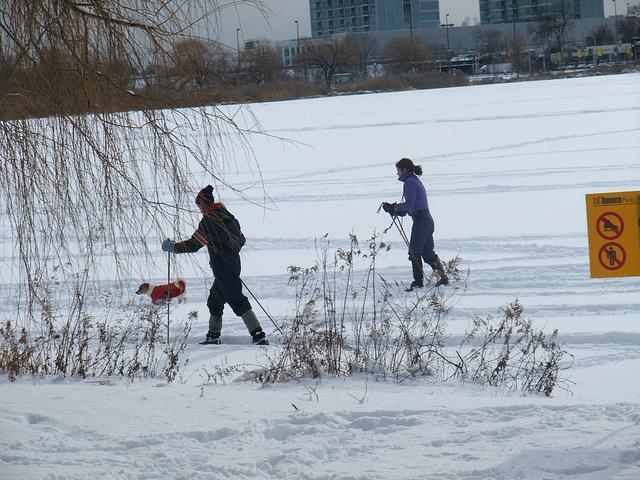What is the first activity that is not allowed on the ice?
Indicate the correct response by choosing from the four available options to answer the question.
Options: Fishing, ice-skating, running, sledding. Ice-skating. 